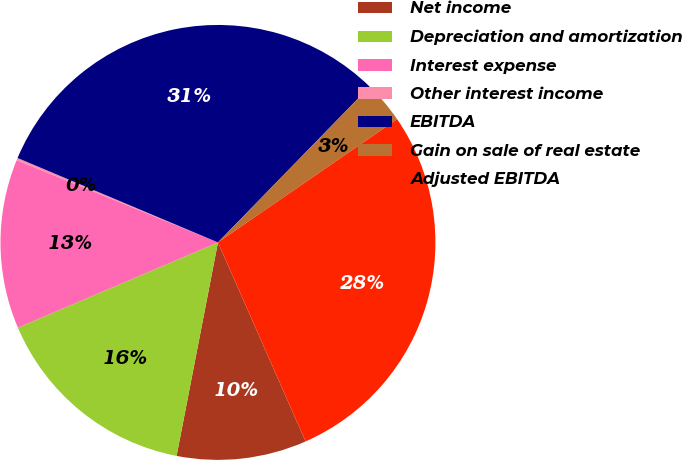Convert chart to OTSL. <chart><loc_0><loc_0><loc_500><loc_500><pie_chart><fcel>Net income<fcel>Depreciation and amortization<fcel>Interest expense<fcel>Other interest income<fcel>EBITDA<fcel>Gain on sale of real estate<fcel>Adjusted EBITDA<nl><fcel>9.65%<fcel>15.54%<fcel>12.59%<fcel>0.17%<fcel>30.94%<fcel>3.12%<fcel>27.99%<nl></chart> 